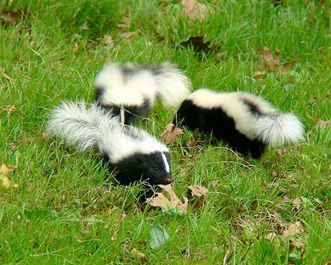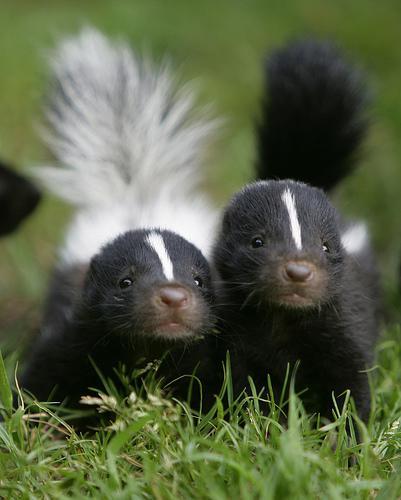The first image is the image on the left, the second image is the image on the right. Assess this claim about the two images: "There is a single skunk in the right image.". Correct or not? Answer yes or no. No. 